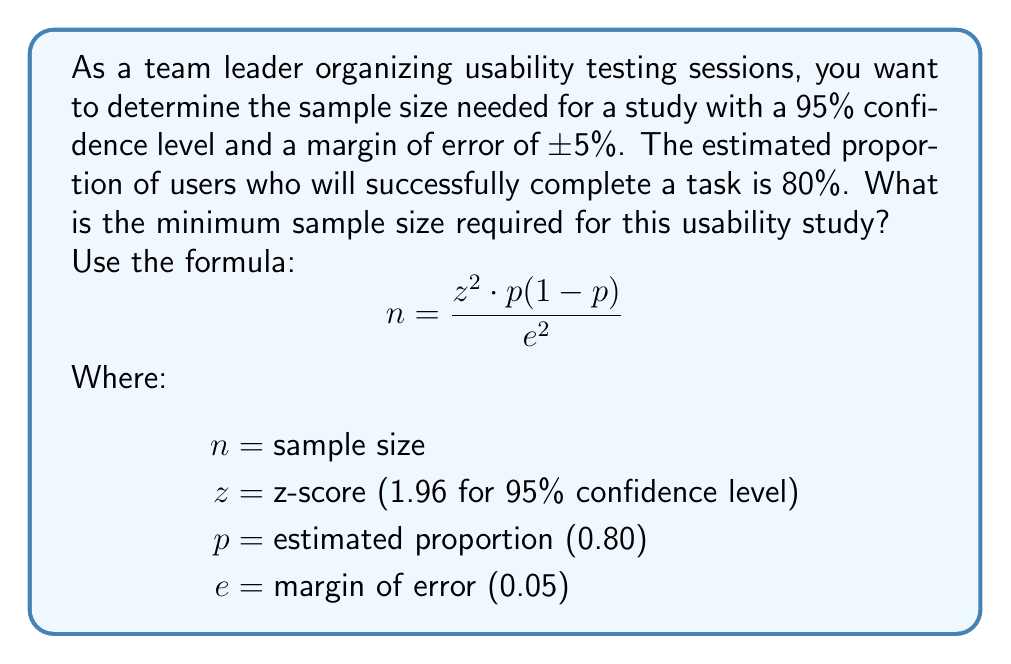Can you answer this question? 1. Identify the given values:
   $z = 1.96$ (for 95% confidence level)
   $p = 0.80$ (estimated proportion)
   $e = 0.05$ (margin of error)

2. Substitute these values into the formula:
   $$n = \frac{1.96^2 \cdot 0.80(1-0.80)}{0.05^2}$$

3. Calculate the numerator:
   $$n = \frac{1.96^2 \cdot 0.80 \cdot 0.20}{0.05^2}$$
   $$n = \frac{3.8416 \cdot 0.16}{0.0025}$$

4. Multiply the values in the numerator:
   $$n = \frac{0.614656}{0.0025}$$

5. Divide to get the final result:
   $$n = 245.8624$$

6. Round up to the nearest whole number, as we can't have a fractional sample size:
   $$n = 246$$

Therefore, the minimum sample size required for this usability study is 246 participants.
Answer: 246 participants 